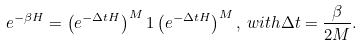<formula> <loc_0><loc_0><loc_500><loc_500>e ^ { - \beta H } = \left ( e ^ { - \Delta t H } \right ) ^ { M } 1 \left ( e ^ { - \Delta t H } \right ) ^ { M } , \, w i t h \Delta t = \frac { \beta } { 2 M } .</formula> 